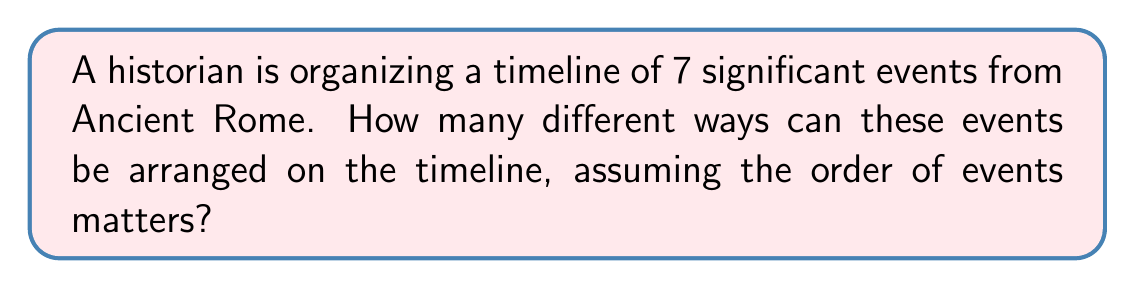Give your solution to this math problem. To solve this problem, we need to use the concept of permutations from combinatorics. Here's a step-by-step explanation:

1) In this case, we are arranging all 7 events, and the order matters (as it's a timeline).

2) When we need to arrange all n items in a specific order, we use the formula for permutations without repetition:

   $$ P(n) = n! $$

   Where $n!$ represents the factorial of $n$.

3) In our case, $n = 7$ (as we have 7 events to arrange).

4) Therefore, we need to calculate $7!$:

   $$ 7! = 7 \times 6 \times 5 \times 4 \times 3 \times 2 \times 1 $$

5) Let's compute this:

   $$ 7! = 7 \times 6 \times 5 \times 4 \times 3 \times 2 \times 1 = 5040 $$

Thus, there are 5040 different ways to arrange these 7 historical events on the timeline.
Answer: 5040 